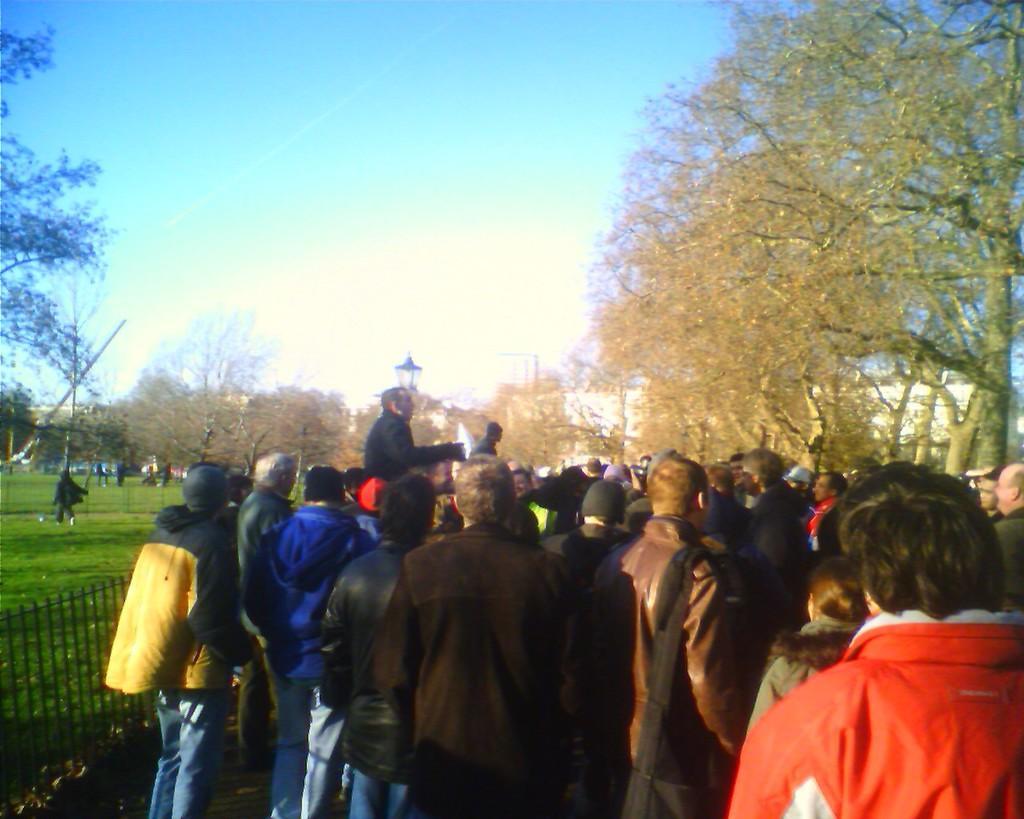Please provide a concise description of this image. In this image there are many people standing. Beside them there is a fencing. Behind the fencing there's grass on the ground. There are a few people standing on the ground. In the background there are trees and houses. At the top there is the sky. 